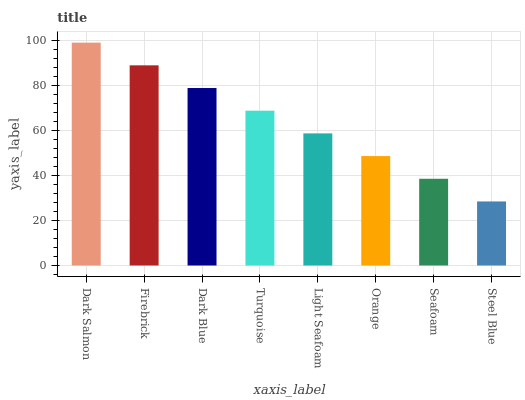Is Firebrick the minimum?
Answer yes or no. No. Is Firebrick the maximum?
Answer yes or no. No. Is Dark Salmon greater than Firebrick?
Answer yes or no. Yes. Is Firebrick less than Dark Salmon?
Answer yes or no. Yes. Is Firebrick greater than Dark Salmon?
Answer yes or no. No. Is Dark Salmon less than Firebrick?
Answer yes or no. No. Is Turquoise the high median?
Answer yes or no. Yes. Is Light Seafoam the low median?
Answer yes or no. Yes. Is Seafoam the high median?
Answer yes or no. No. Is Seafoam the low median?
Answer yes or no. No. 